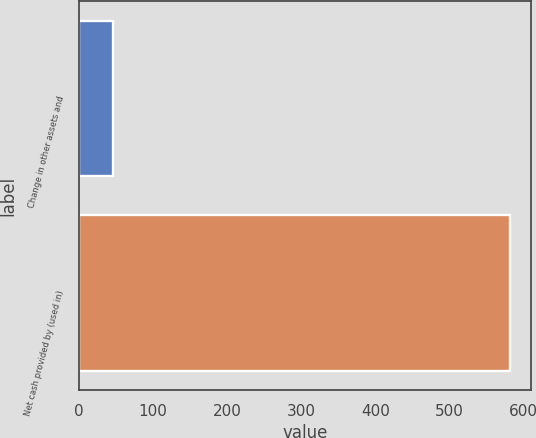<chart> <loc_0><loc_0><loc_500><loc_500><bar_chart><fcel>Change in other assets and<fcel>Net cash provided by (used in)<nl><fcel>45.6<fcel>581.5<nl></chart> 